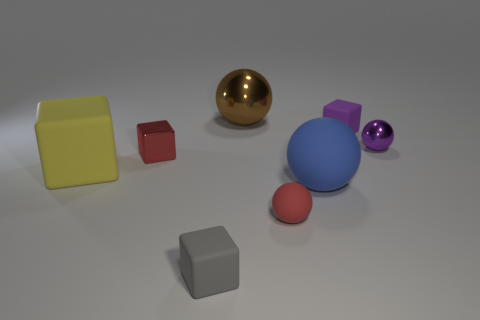Are there any blue spheres to the right of the big blue sphere?
Provide a short and direct response. No. There is a large matte thing that is on the left side of the brown object; is it the same shape as the small gray rubber thing?
Your answer should be very brief. Yes. What material is the block that is the same color as the tiny metal sphere?
Your answer should be compact. Rubber. What number of things have the same color as the metallic cube?
Your answer should be very brief. 1. The large yellow object that is in front of the small object behind the purple sphere is what shape?
Keep it short and to the point. Cube. Is there a purple shiny object of the same shape as the brown metal object?
Provide a succinct answer. Yes. Is the color of the small shiny cube the same as the tiny sphere in front of the red metallic cube?
Make the answer very short. Yes. Is there another purple sphere that has the same size as the purple ball?
Keep it short and to the point. No. Do the gray object and the block that is to the right of the small red matte object have the same material?
Offer a very short reply. Yes. Are there more rubber blocks than objects?
Give a very brief answer. No. 